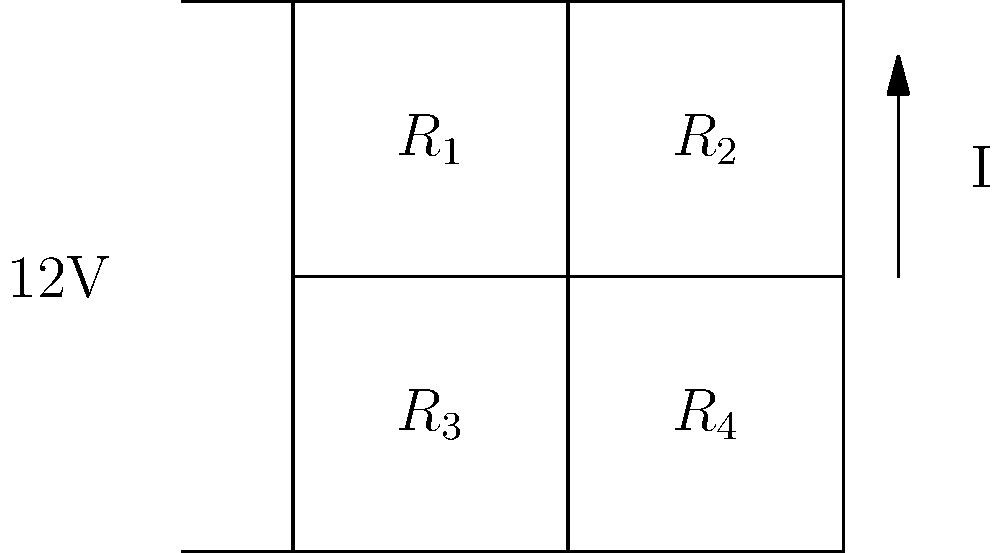In the resistor network shown, if $R_1 = 2\Omega$, $R_2 = 4\Omega$, $R_3 = 3\Omega$, and $R_4 = 6\Omega$, calculate the total power dissipated in the network. How might this power dissipation compare to the heat generated during the coffee bean roasting process? To solve this problem, we'll follow these steps:

1. Calculate the equivalent resistance of the network:
   - $R_{12} = R_1 + R_2 = 2\Omega + 4\Omega = 6\Omega$
   - $R_{34} = R_3 + R_4 = 3\Omega + 6\Omega = 9\Omega$
   - $R_{eq} = \frac{1}{\frac{1}{R_{12}} + \frac{1}{R_{34}}} = \frac{1}{\frac{1}{6} + \frac{1}{9}} = \frac{18}{5} = 3.6\Omega$

2. Calculate the total current using Ohm's law:
   $I = \frac{V}{R_{eq}} = \frac{12V}{3.6\Omega} = 3.33A$

3. Calculate the power dissipated in each branch:
   - $P_{12} = I_{12}^2 \cdot R_{12} = (3.33A \cdot \frac{9}{15})^2 \cdot 6\Omega = 24W$
   - $P_{34} = I_{34}^2 \cdot R_{34} = (3.33A \cdot \frac{6}{15})^2 \cdot 9\Omega = 16W$

4. Calculate the total power dissipated:
   $P_{total} = P_{12} + P_{34} = 24W + 16W = 40W$

The total power dissipated in the network is 40W. This amount of power is relatively small compared to the heat generated during coffee bean roasting, which typically requires several kilowatts of power. The roasting process usually involves temperatures between 180°C and 240°C, requiring significantly more energy than this electrical circuit dissipates.
Answer: 40W 